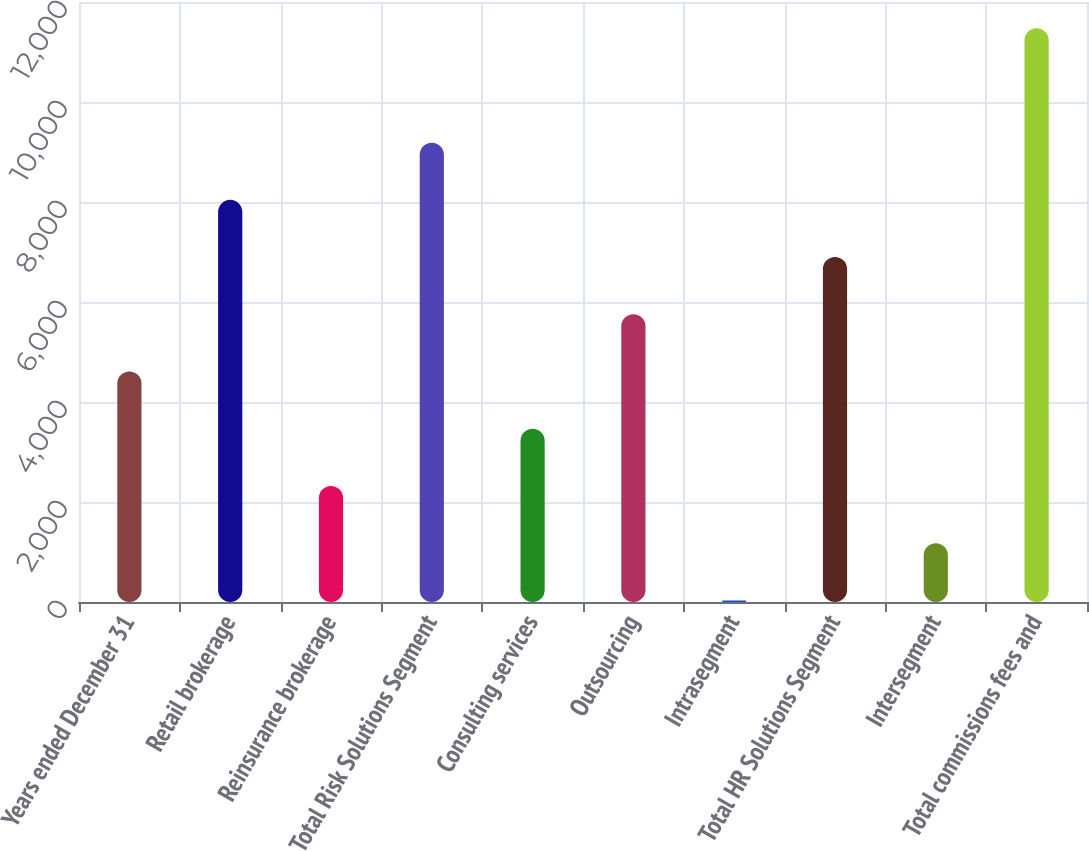Convert chart. <chart><loc_0><loc_0><loc_500><loc_500><bar_chart><fcel>Years ended December 31<fcel>Retail brokerage<fcel>Reinsurance brokerage<fcel>Total Risk Solutions Segment<fcel>Consulting services<fcel>Outsourcing<fcel>Intrasegment<fcel>Total HR Solutions Segment<fcel>Intersegment<fcel>Total commissions fees and<nl><fcel>4609.6<fcel>8042.8<fcel>2320.8<fcel>9187.2<fcel>3465.2<fcel>5754<fcel>32<fcel>6898.4<fcel>1176.4<fcel>11476<nl></chart> 